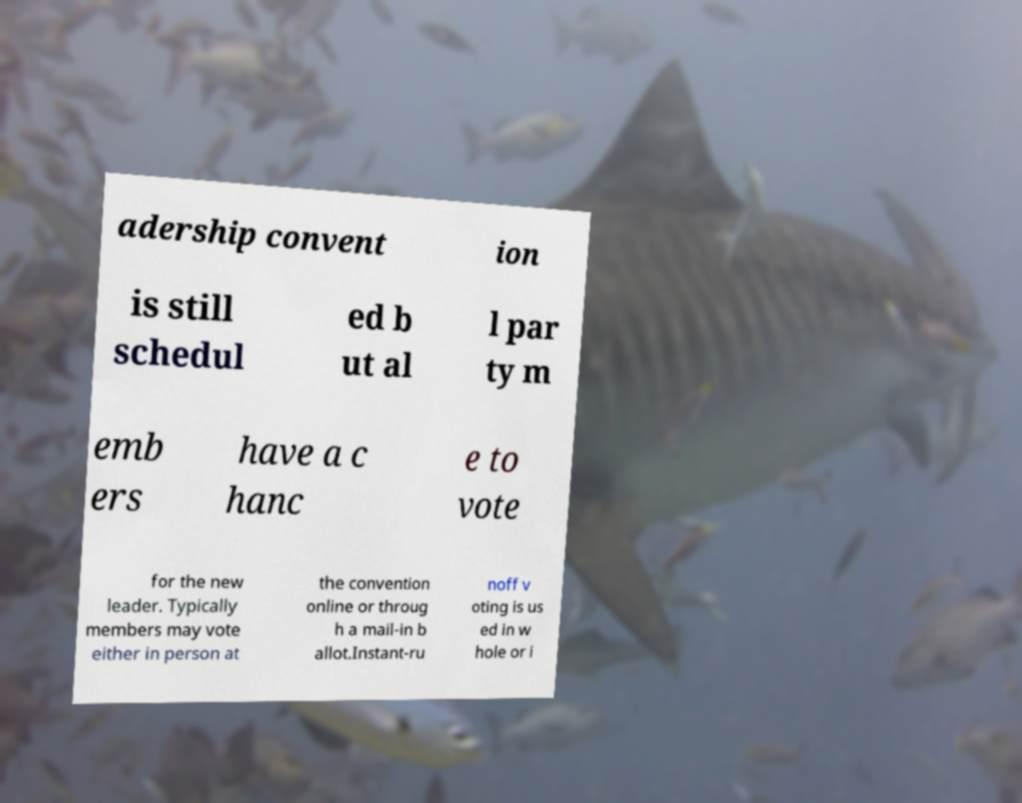Please read and relay the text visible in this image. What does it say? adership convent ion is still schedul ed b ut al l par ty m emb ers have a c hanc e to vote for the new leader. Typically members may vote either in person at the convention online or throug h a mail-in b allot.Instant-ru noff v oting is us ed in w hole or i 